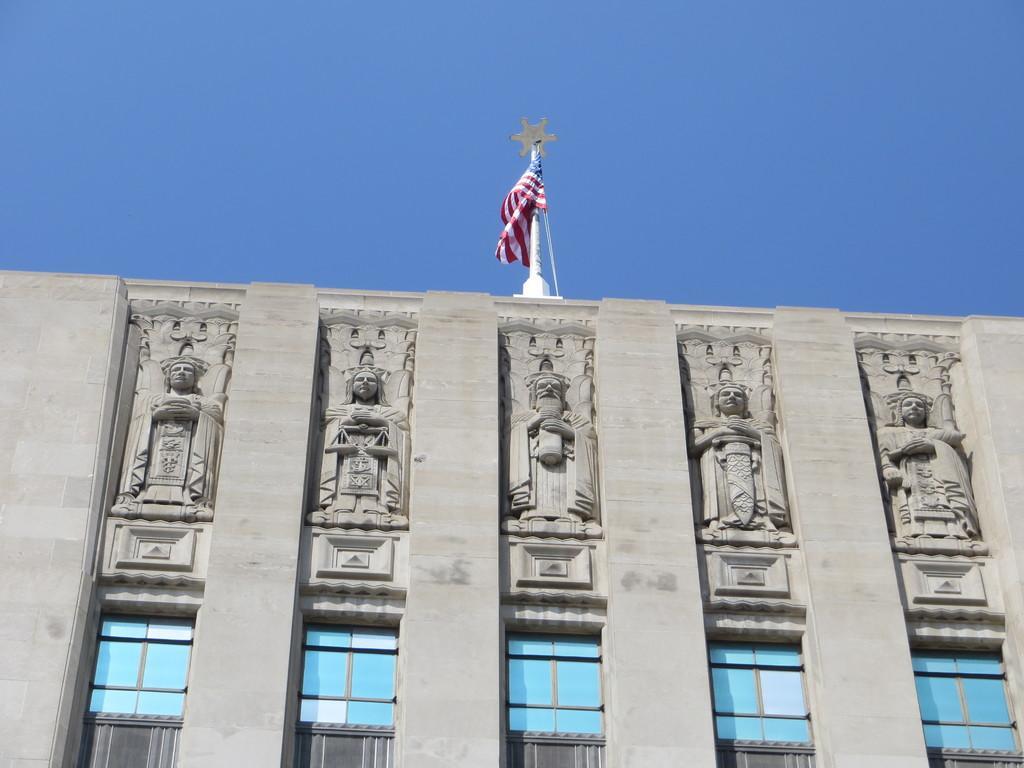In one or two sentences, can you explain what this image depicts? In this image I can see the building with statues and windows. I can see the flag at the top of the building. In the background I can see the sky. 